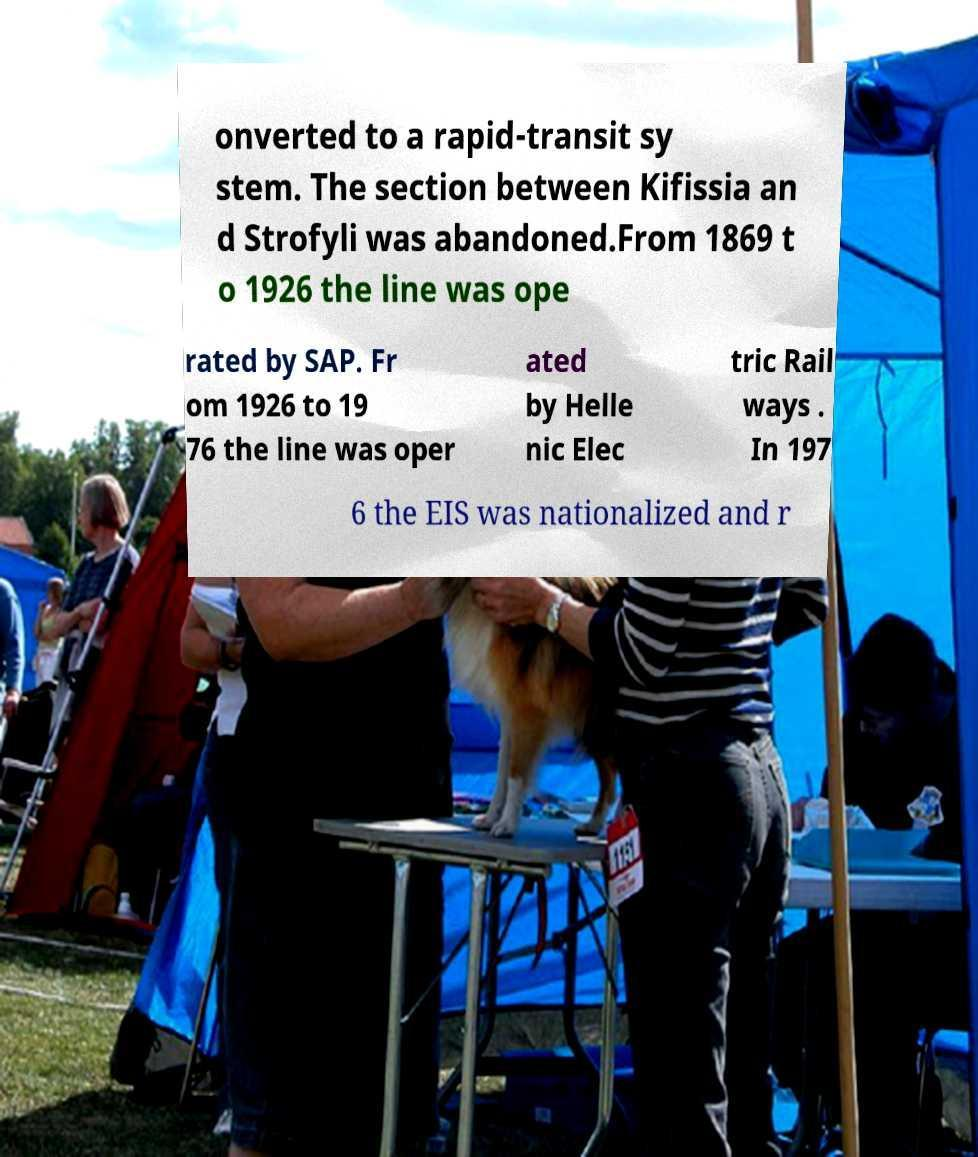Could you assist in decoding the text presented in this image and type it out clearly? onverted to a rapid-transit sy stem. The section between Kifissia an d Strofyli was abandoned.From 1869 t o 1926 the line was ope rated by SAP. Fr om 1926 to 19 76 the line was oper ated by Helle nic Elec tric Rail ways . In 197 6 the EIS was nationalized and r 